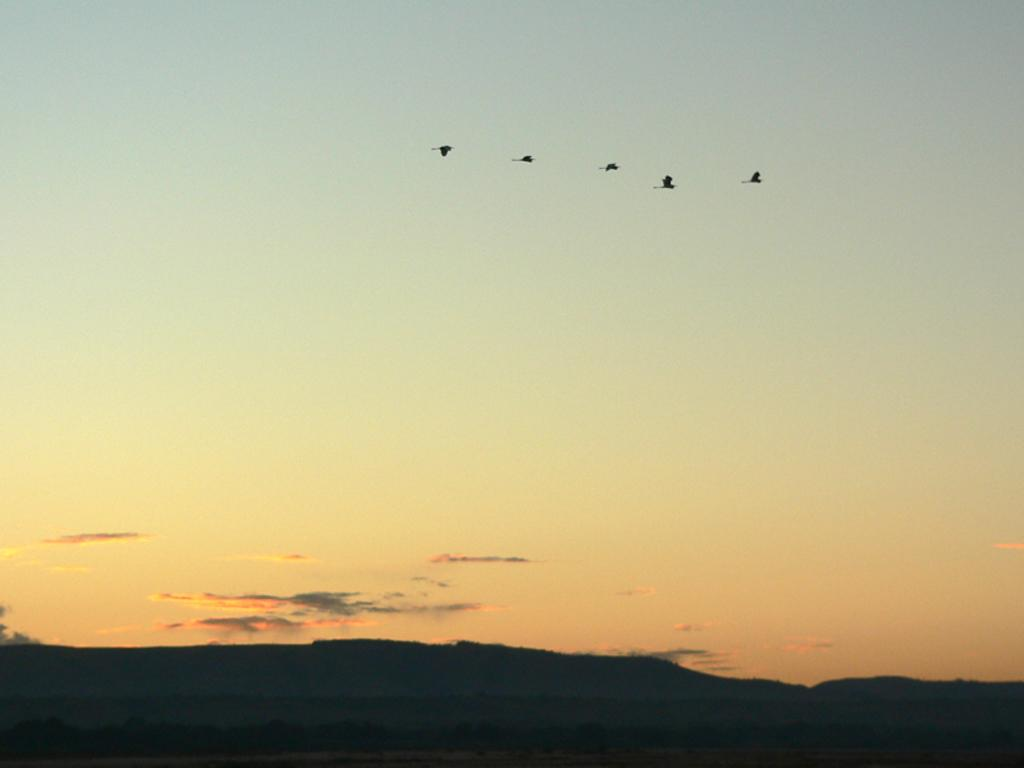What type of landscape can be seen in the image? There are hills in the image. How would you describe the appearance of the hills? The hills are dark. What else is visible in the sky besides the clouds? Sunshine is present in the image. What animals can be seen in the image? There are birds flying in the air. What type of haircut is the hill getting in the image? The hill is not getting a haircut, as it is a natural landscape feature and not a living being. How does the hill's stomach feel after eating the clouds? The hill does not have a stomach, as it is a natural landscape feature and not a living being. 